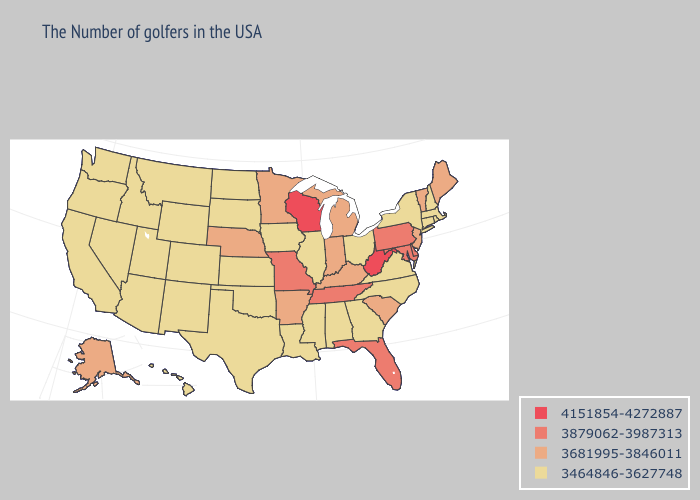Which states hav the highest value in the West?
Short answer required. Alaska. Does Iowa have a lower value than Texas?
Answer briefly. No. Does Texas have the lowest value in the South?
Keep it brief. Yes. How many symbols are there in the legend?
Give a very brief answer. 4. Among the states that border Delaware , does New Jersey have the lowest value?
Concise answer only. Yes. Name the states that have a value in the range 3681995-3846011?
Answer briefly. Maine, Vermont, New Jersey, South Carolina, Michigan, Kentucky, Indiana, Arkansas, Minnesota, Nebraska, Alaska. What is the value of New Mexico?
Be succinct. 3464846-3627748. Does Maryland have the lowest value in the South?
Short answer required. No. Name the states that have a value in the range 3681995-3846011?
Quick response, please. Maine, Vermont, New Jersey, South Carolina, Michigan, Kentucky, Indiana, Arkansas, Minnesota, Nebraska, Alaska. Name the states that have a value in the range 4151854-4272887?
Be succinct. West Virginia, Wisconsin. Name the states that have a value in the range 4151854-4272887?
Answer briefly. West Virginia, Wisconsin. Name the states that have a value in the range 4151854-4272887?
Give a very brief answer. West Virginia, Wisconsin. Name the states that have a value in the range 3464846-3627748?
Write a very short answer. Massachusetts, Rhode Island, New Hampshire, Connecticut, New York, Virginia, North Carolina, Ohio, Georgia, Alabama, Illinois, Mississippi, Louisiana, Iowa, Kansas, Oklahoma, Texas, South Dakota, North Dakota, Wyoming, Colorado, New Mexico, Utah, Montana, Arizona, Idaho, Nevada, California, Washington, Oregon, Hawaii. What is the value of Nevada?
Keep it brief. 3464846-3627748. How many symbols are there in the legend?
Give a very brief answer. 4. 